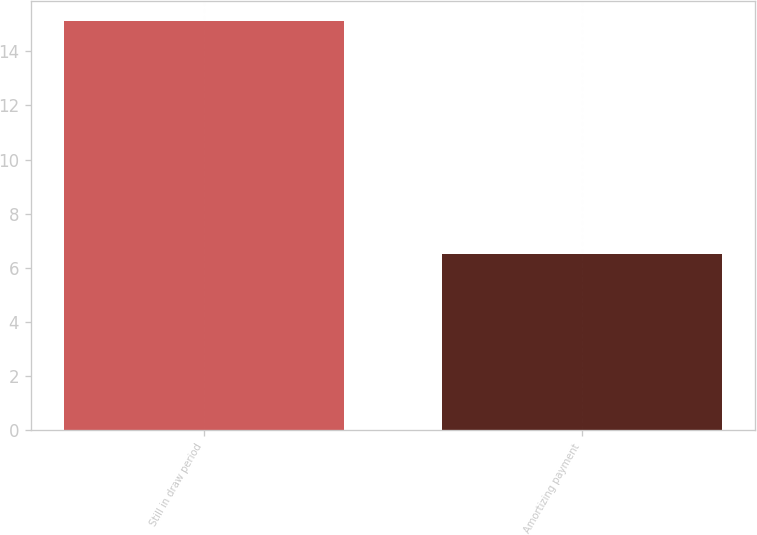Convert chart. <chart><loc_0><loc_0><loc_500><loc_500><bar_chart><fcel>Still in draw period<fcel>Amortizing payment<nl><fcel>15.1<fcel>6.5<nl></chart> 